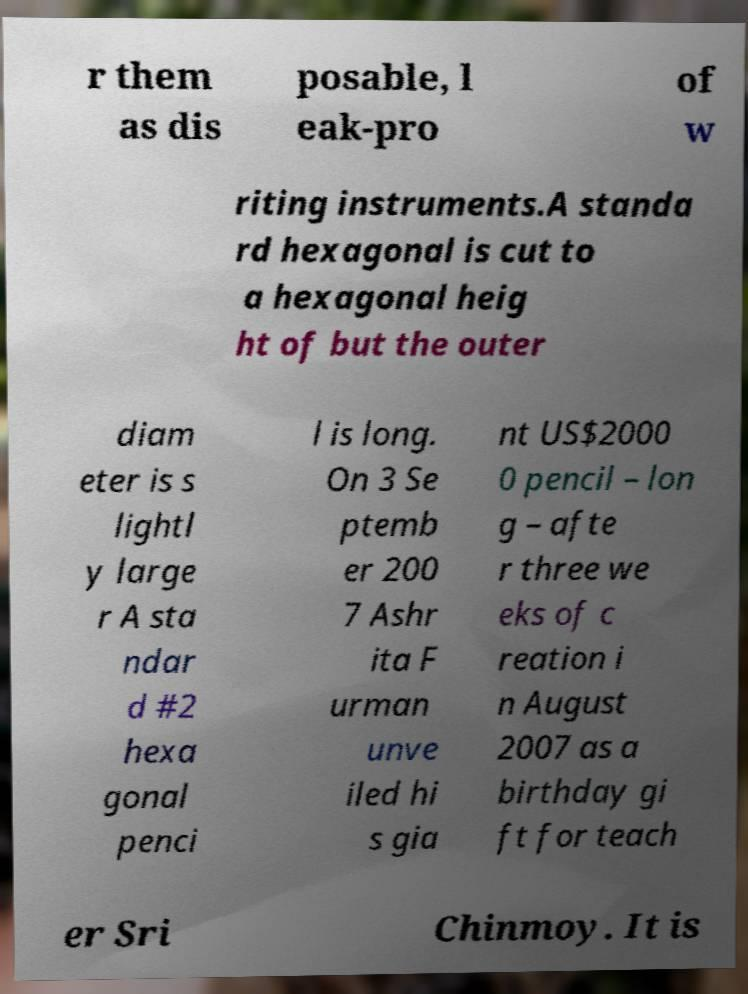Please read and relay the text visible in this image. What does it say? r them as dis posable, l eak-pro of w riting instruments.A standa rd hexagonal is cut to a hexagonal heig ht of but the outer diam eter is s lightl y large r A sta ndar d #2 hexa gonal penci l is long. On 3 Se ptemb er 200 7 Ashr ita F urman unve iled hi s gia nt US$2000 0 pencil – lon g – afte r three we eks of c reation i n August 2007 as a birthday gi ft for teach er Sri Chinmoy. It is 